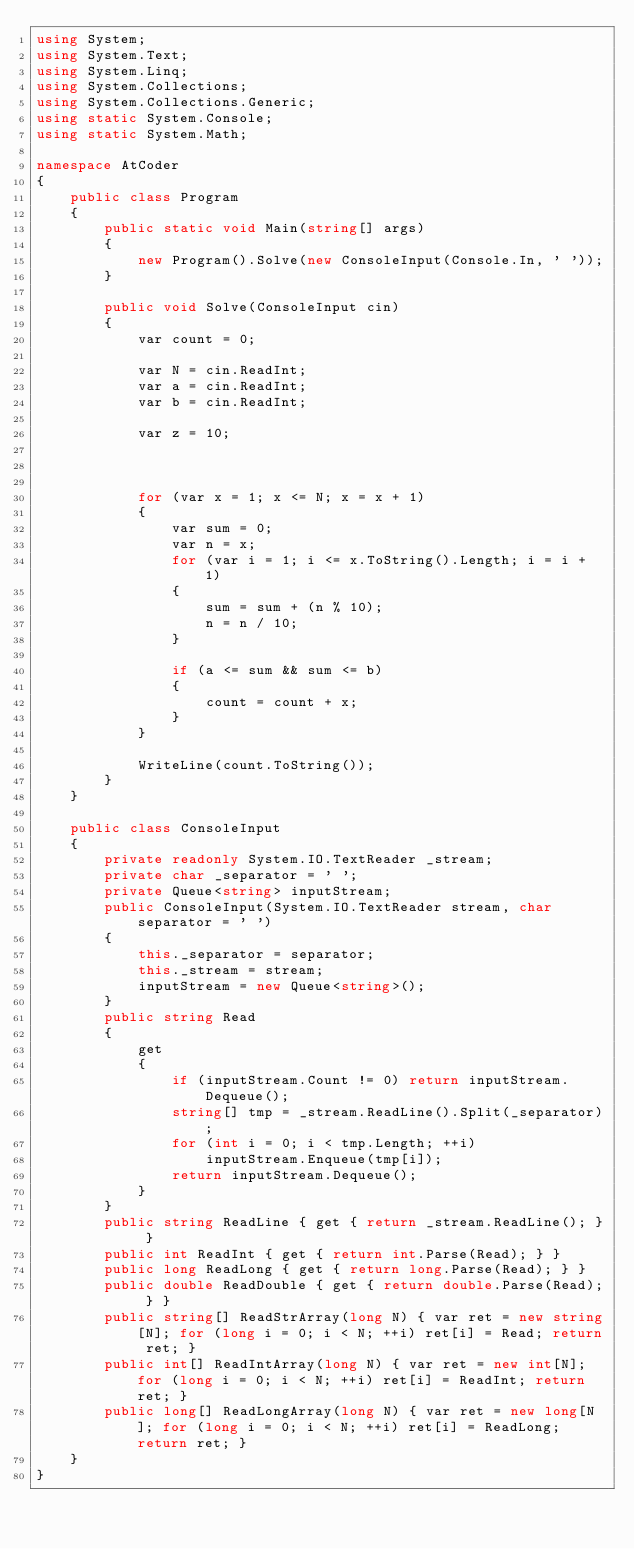<code> <loc_0><loc_0><loc_500><loc_500><_C#_>using System;
using System.Text;
using System.Linq;
using System.Collections;
using System.Collections.Generic;
using static System.Console;
using static System.Math;

namespace AtCoder
{
    public class Program
    {
        public static void Main(string[] args)
        {
            new Program().Solve(new ConsoleInput(Console.In, ' '));
        }

        public void Solve(ConsoleInput cin)
        {
            var count = 0;

            var N = cin.ReadInt;
            var a = cin.ReadInt;
            var b = cin.ReadInt;

            var z = 10;

            

            for (var x = 1; x <= N; x = x + 1)
            {
                var sum = 0;
                var n = x;
                for (var i = 1; i <= x.ToString().Length; i = i + 1)
                {
                    sum = sum + (n % 10);
                    n = n / 10;
                }

                if (a <= sum && sum <= b)
                {
                    count = count + x;
                }
            }

            WriteLine(count.ToString());
        }
    }

    public class ConsoleInput
    {
        private readonly System.IO.TextReader _stream;
        private char _separator = ' ';
        private Queue<string> inputStream;
        public ConsoleInput(System.IO.TextReader stream, char separator = ' ')
        {
            this._separator = separator;
            this._stream = stream;
            inputStream = new Queue<string>();
        }
        public string Read
        {
            get
            {
                if (inputStream.Count != 0) return inputStream.Dequeue();
                string[] tmp = _stream.ReadLine().Split(_separator);
                for (int i = 0; i < tmp.Length; ++i)
                    inputStream.Enqueue(tmp[i]);
                return inputStream.Dequeue();
            }
        }
        public string ReadLine { get { return _stream.ReadLine(); } }
        public int ReadInt { get { return int.Parse(Read); } }
        public long ReadLong { get { return long.Parse(Read); } }
        public double ReadDouble { get { return double.Parse(Read); } }
        public string[] ReadStrArray(long N) { var ret = new string[N]; for (long i = 0; i < N; ++i) ret[i] = Read; return ret; }
        public int[] ReadIntArray(long N) { var ret = new int[N]; for (long i = 0; i < N; ++i) ret[i] = ReadInt; return ret; }
        public long[] ReadLongArray(long N) { var ret = new long[N]; for (long i = 0; i < N; ++i) ret[i] = ReadLong; return ret; }
    }
}</code> 